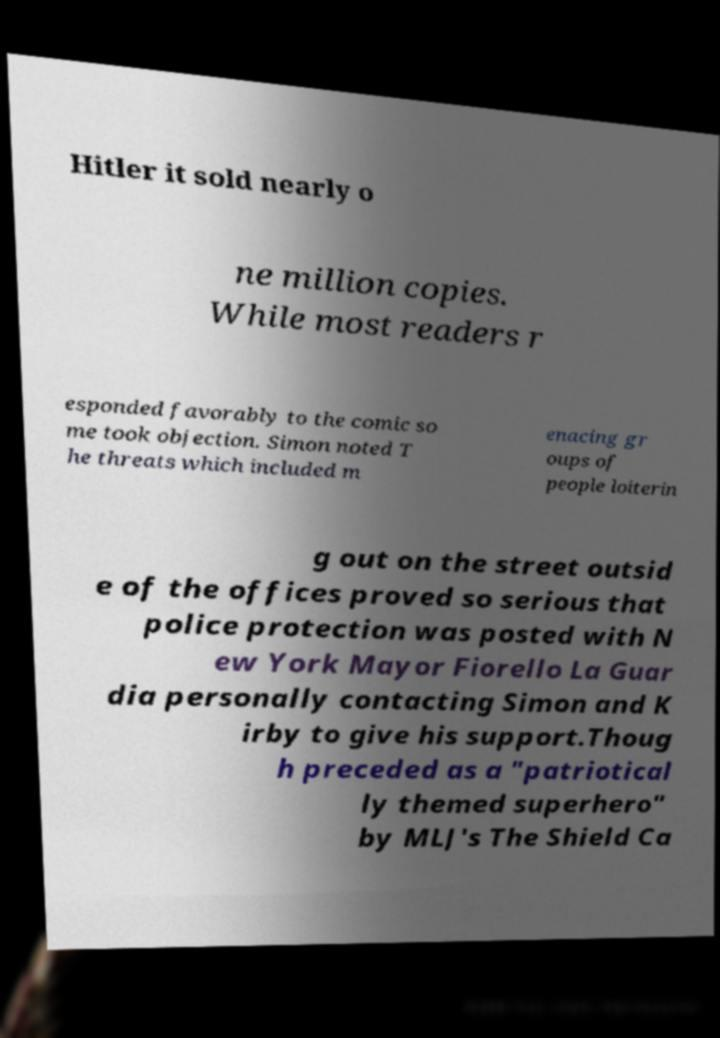Please identify and transcribe the text found in this image. Hitler it sold nearly o ne million copies. While most readers r esponded favorably to the comic so me took objection. Simon noted T he threats which included m enacing gr oups of people loiterin g out on the street outsid e of the offices proved so serious that police protection was posted with N ew York Mayor Fiorello La Guar dia personally contacting Simon and K irby to give his support.Thoug h preceded as a "patriotical ly themed superhero" by MLJ's The Shield Ca 